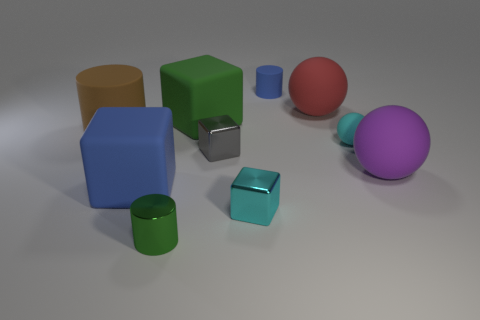Subtract all cyan cubes. How many cubes are left? 3 Subtract 1 balls. How many balls are left? 2 Subtract all cyan cubes. How many cubes are left? 3 Subtract all gray cylinders. Subtract all gray spheres. How many cylinders are left? 3 Subtract 0 blue spheres. How many objects are left? 10 Subtract all spheres. How many objects are left? 7 Subtract all large gray cubes. Subtract all green matte objects. How many objects are left? 9 Add 5 tiny green metallic cylinders. How many tiny green metallic cylinders are left? 6 Add 1 large red matte balls. How many large red matte balls exist? 2 